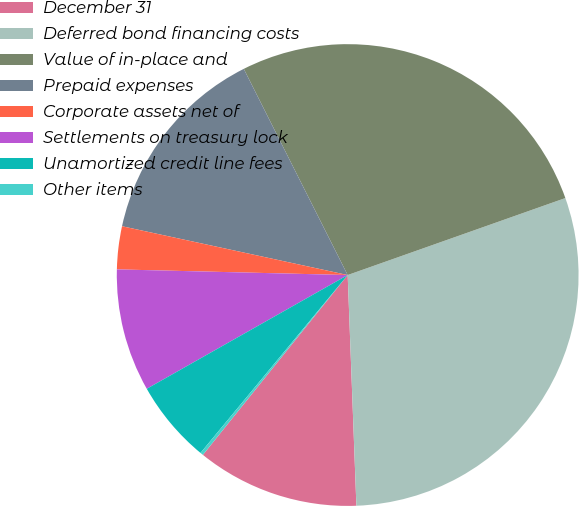<chart> <loc_0><loc_0><loc_500><loc_500><pie_chart><fcel>December 31<fcel>Deferred bond financing costs<fcel>Value of in-place and<fcel>Prepaid expenses<fcel>Corporate assets net of<fcel>Settlements on treasury lock<fcel>Unamortized credit line fees<fcel>Other items<nl><fcel>11.39%<fcel>29.81%<fcel>27.02%<fcel>14.18%<fcel>3.0%<fcel>8.59%<fcel>5.8%<fcel>0.21%<nl></chart> 